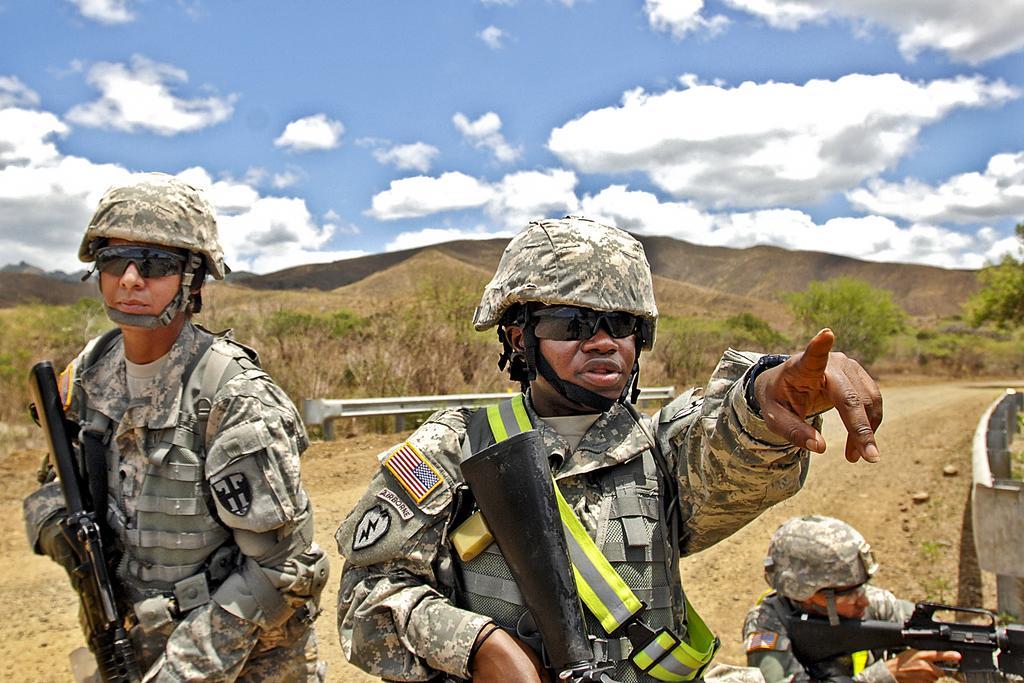How would you summarize this image in a sentence or two? In this picture I can see couple of them standing and holding guns in their hands and they are wearing helmets on their heads and sunglasses and I can see another man holding a gun on the side and I can see hills, trees and few plants and I can see a blue cloudy sky. 